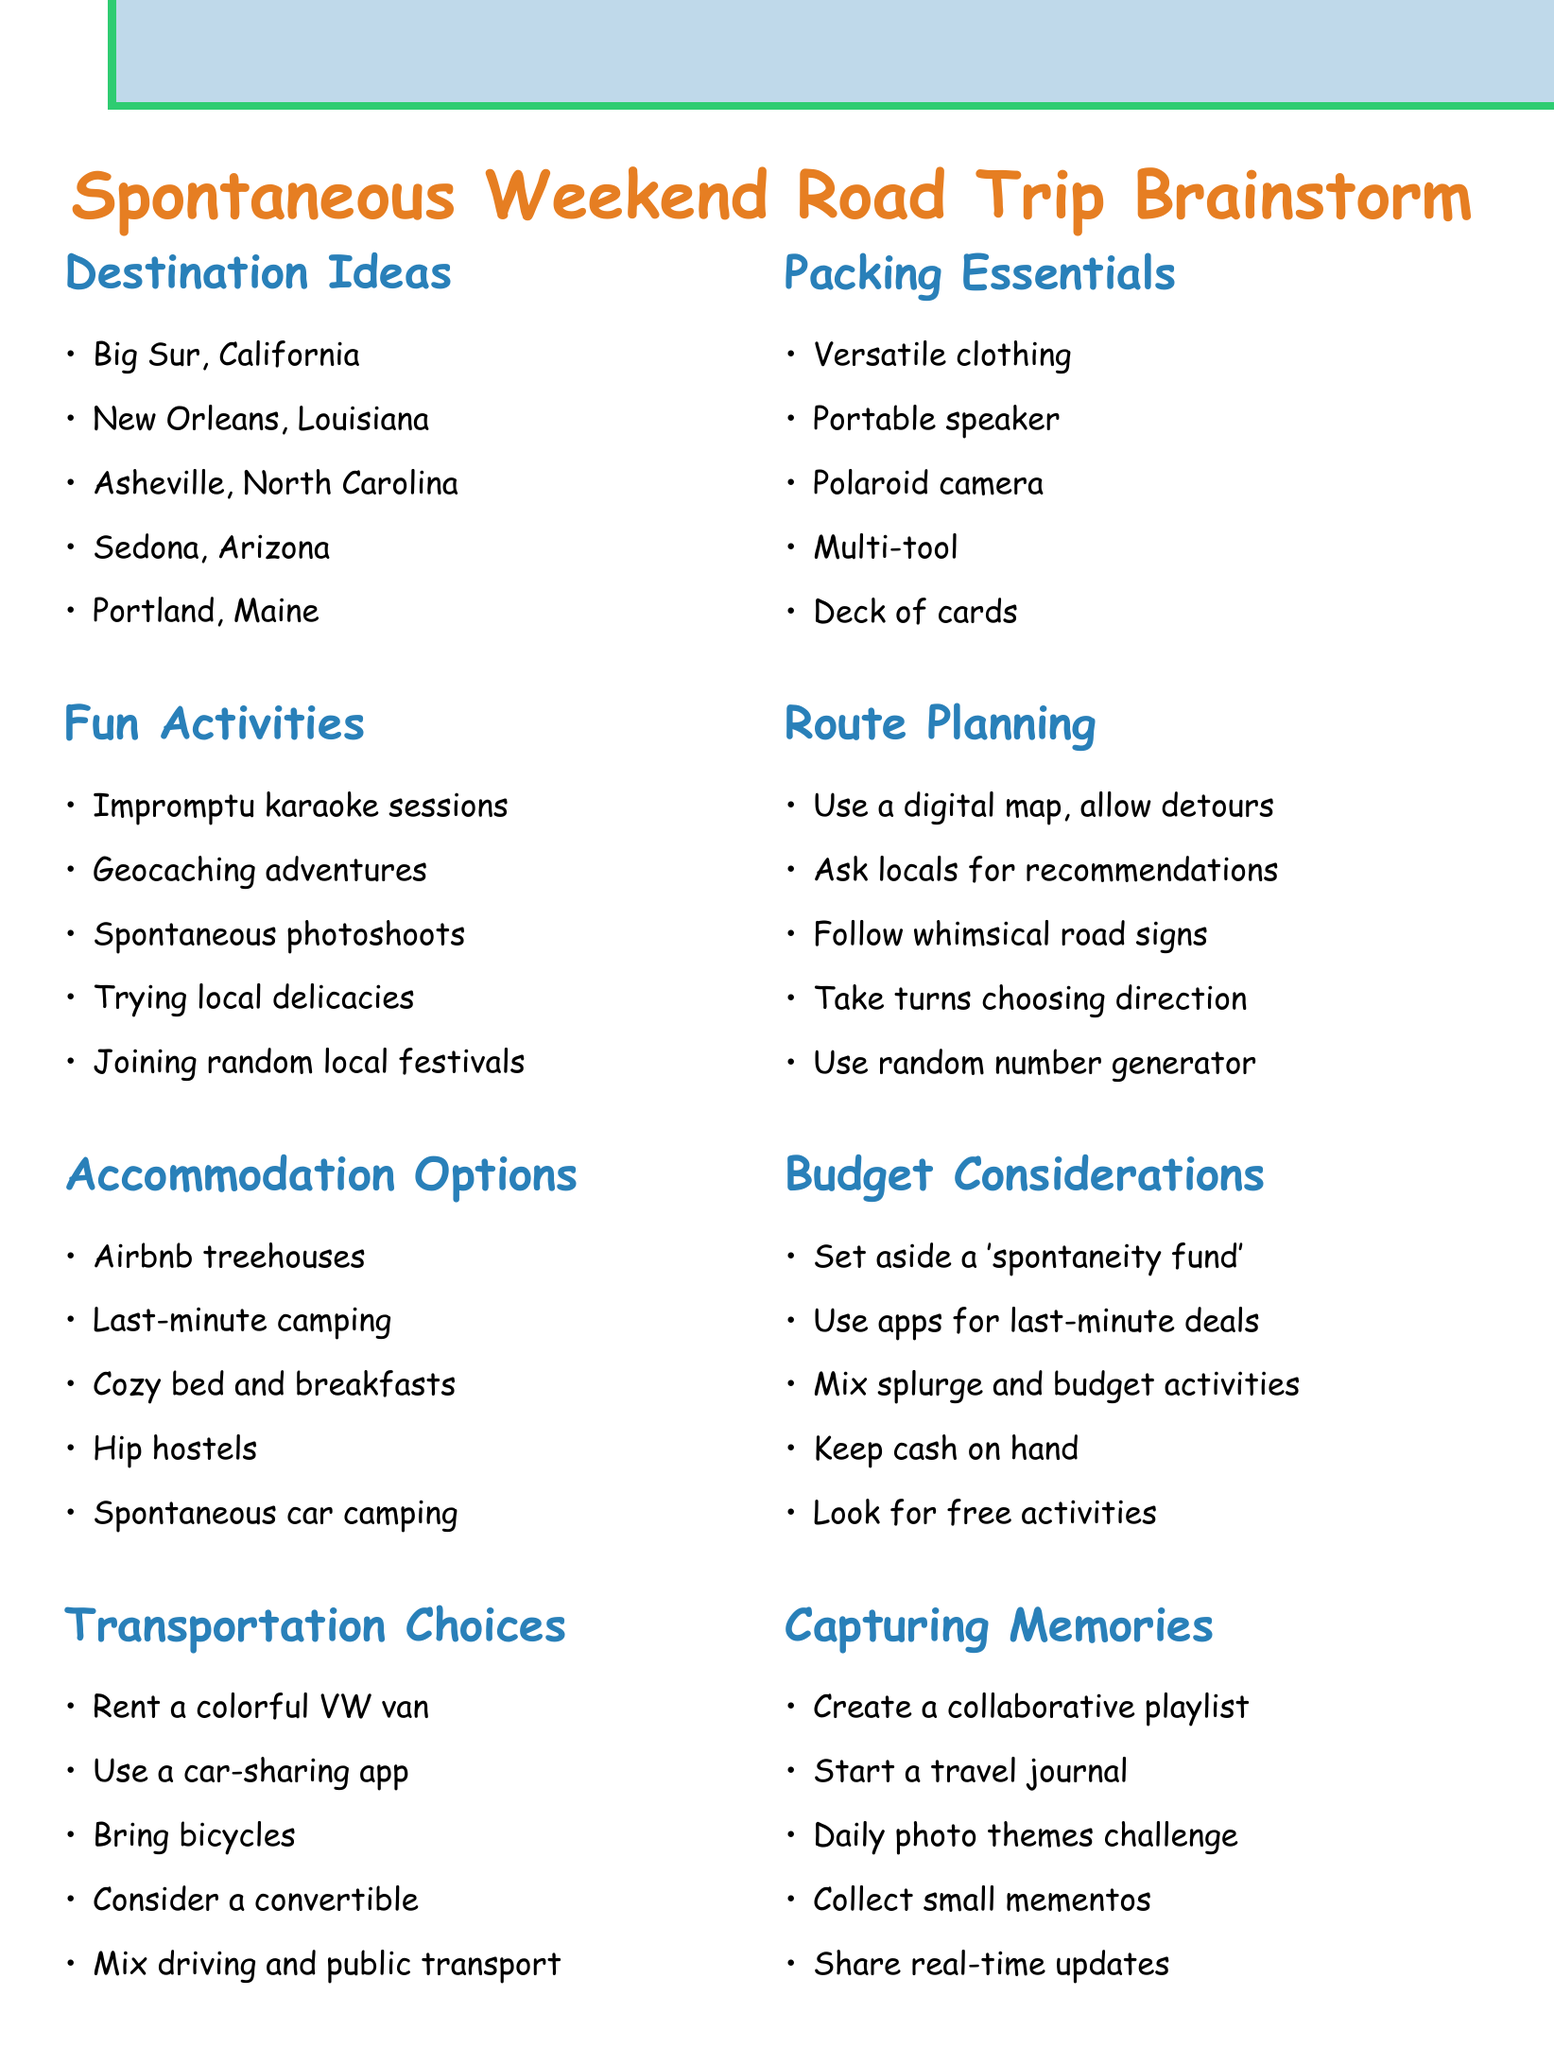What are some destination ideas? The document lists several locations that are suggested for the road trip, such as Big Sur and New Orleans.
Answer: Big Sur, New Orleans, Asheville, Sedona, Portland What is one fun activity mentioned in the agenda? The document includes several activities that can be done during the road trip, including karaoke sessions.
Answer: Impromptu karaoke sessions What type of accommodation options are suggested? The document provides a list of unique accommodations such as treehouses and camping.
Answer: Airbnb treehouses What kind of transportation choices can be made? The document outlines various options for transportation, including renting vehicles and using bikes.
Answer: Rent a colorful VW van What is advised for packing essentials? The document emphasizes the importance of packing versatile clothing and a portable speaker for spontaneity.
Answer: Versatile clothing How can spontaneity be included in route planning? The agenda mentions methods to keep the route flexible, such as allowing for detours and asking locals.
Answer: Allow for detours What budget consideration is mentioned in the document? The document suggests having a reserve fund specifically for spontaneous activities.
Answer: 'Spontaneity fund' Name a way to capture memories on the trip. Various methods for memory capture are suggested, including creating a collaborative playlist.
Answer: Create a collaborative playlist 